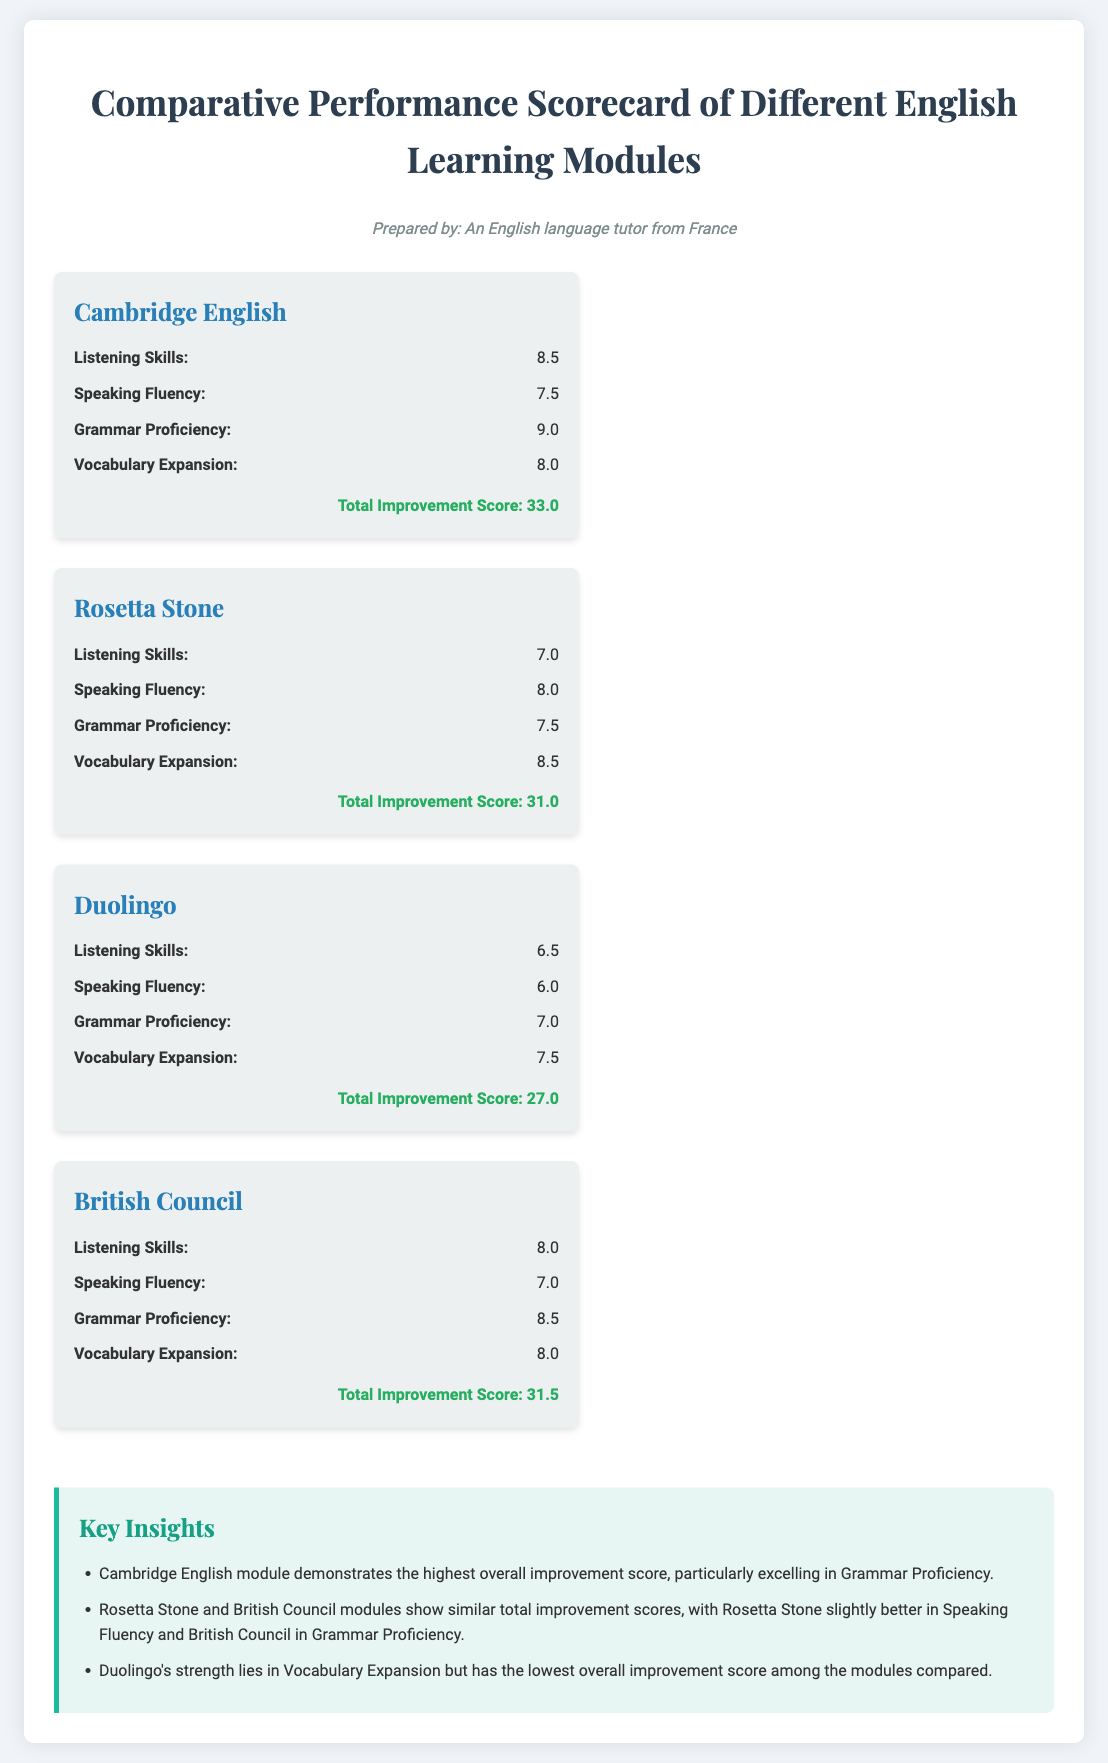What is the total improvement score of Cambridge English? The total improvement score for Cambridge English is specified in the document as 33.0.
Answer: 33.0 Which module has the lowest score in Listening Skills? The module with the lowest score in Listening Skills is Duolingo, which has a score of 6.5.
Answer: Duolingo What is the score for Speaking Fluency in the British Council module? The document states that the score for Speaking Fluency in the British Council module is 7.0.
Answer: 7.0 Which module excels in Vocabulary Expansion? The score for Vocabulary Expansion indicates that Duolingo, with a score of 7.5, is the strongest but not overall.
Answer: Duolingo How do the total improvement scores of Rosetta Stone and British Council compare? The total improvement scores show Rosetta Stone has a score of 31.0, while British Council has a slightly higher score of 31.5.
Answer: 31.0 & 31.5 Which skill category received the highest score across all modules? The highest score in a skill category is for Grammar Proficiency in Cambridge English with a score of 9.0.
Answer: 9.0 What unique insight is given about the Duolingo module? The document notes that Duolingo has the lowest overall improvement score among the compared modules.
Answer: Lowest overall improvement score What are the total improvement scores for the modules ranked in decreasing order? According to the document, the scores are: Cambridge English (33.0), British Council (31.5), Rosetta Stone (31.0), Duolingo (27.0).
Answer: 33.0, 31.5, 31.0, 27.0 